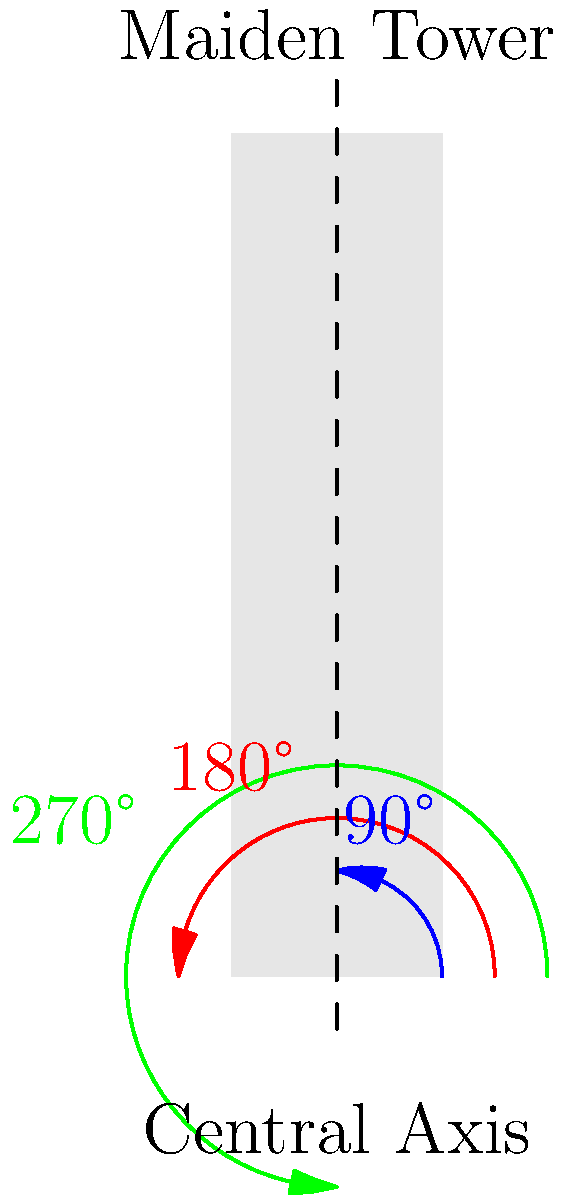The Maiden Tower in Baku, a symbol of Azerbaijan's rich cultural heritage, is being studied for its symmetrical properties. If the tower is rotated around its central axis by 90°, 180°, and 270°, how many unique orientations of the tower will be visible, assuming it has a perfectly symmetrical square base? Let's approach this step-by-step:

1) First, we need to understand what a "unique orientation" means. It's a position of the tower that looks different from other positions.

2) The tower has a square base, which is important for this problem. A square has rotational symmetry of order 4, meaning it looks the same after every 90° rotation.

3) Let's consider each rotation:
   - 0° (original position): This is our starting point.
   - 90° rotation: This will look the same as the original position due to the square base.
   - 180° rotation: This will also look the same as the original position.
   - 270° rotation: Again, this will look the same as the original position.

4) No matter how many times we rotate the tower by these angles, we will always see the same orientation due to the symmetry of the square base.

5) Therefore, there is only one unique orientation visible throughout all these rotations.

This problem highlights the importance of symmetry in architecture, a concept that transcends cultural boundaries and speaks to the universal language of mathematics and design.
Answer: 1 unique orientation 